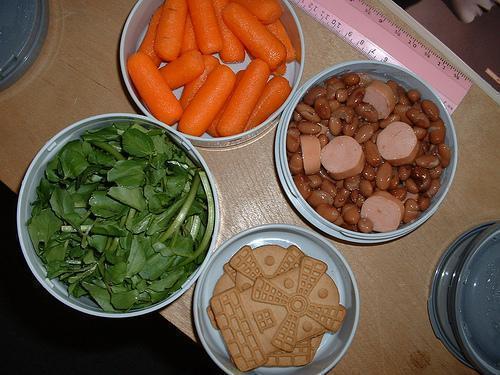What is the cookie in the shape of?
Indicate the correct response by choosing from the four available options to answer the question.
Options: Windmill, apple, cat, baby. Windmill. 